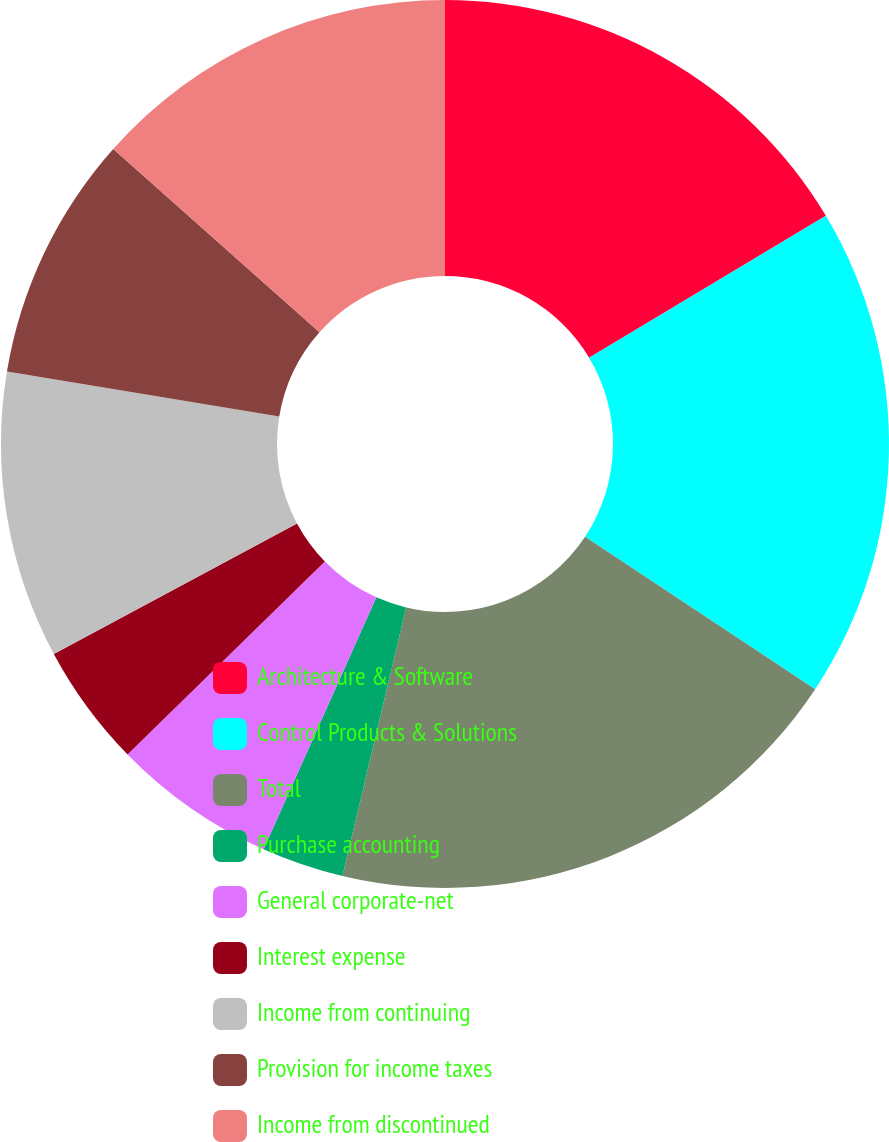Convert chart. <chart><loc_0><loc_0><loc_500><loc_500><pie_chart><fcel>Architecture & Software<fcel>Control Products & Solutions<fcel>Total<fcel>Purchase accounting<fcel>General corporate-net<fcel>Interest expense<fcel>Income from continuing<fcel>Provision for income taxes<fcel>Income from discontinued<nl><fcel>16.41%<fcel>17.9%<fcel>19.4%<fcel>2.99%<fcel>5.98%<fcel>4.48%<fcel>10.45%<fcel>8.96%<fcel>13.43%<nl></chart> 